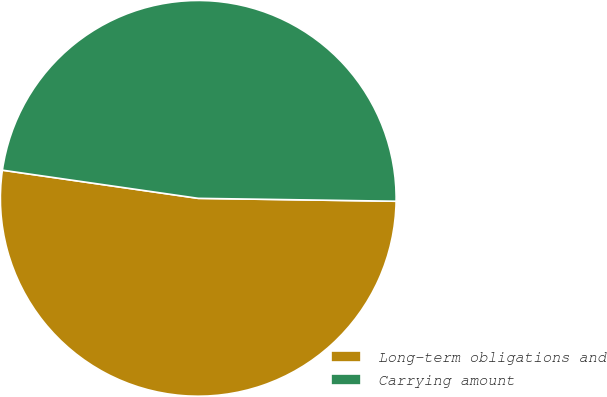Convert chart to OTSL. <chart><loc_0><loc_0><loc_500><loc_500><pie_chart><fcel>Long-term obligations and<fcel>Carrying amount<nl><fcel>52.04%<fcel>47.96%<nl></chart> 